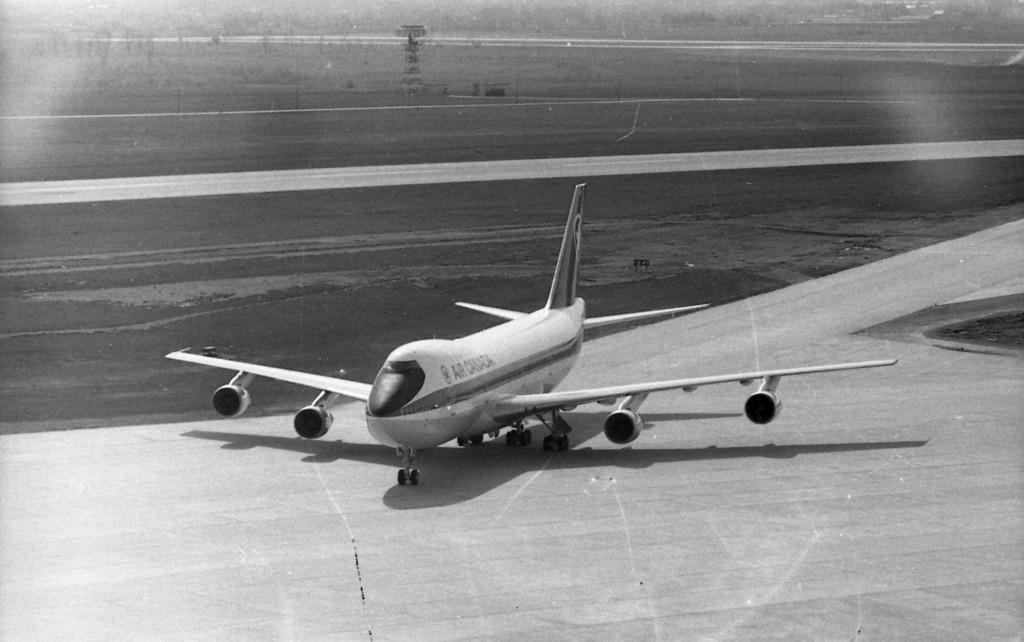<image>
Describe the image concisely. A black and white image of an Air Canada plane on a tarmac. 